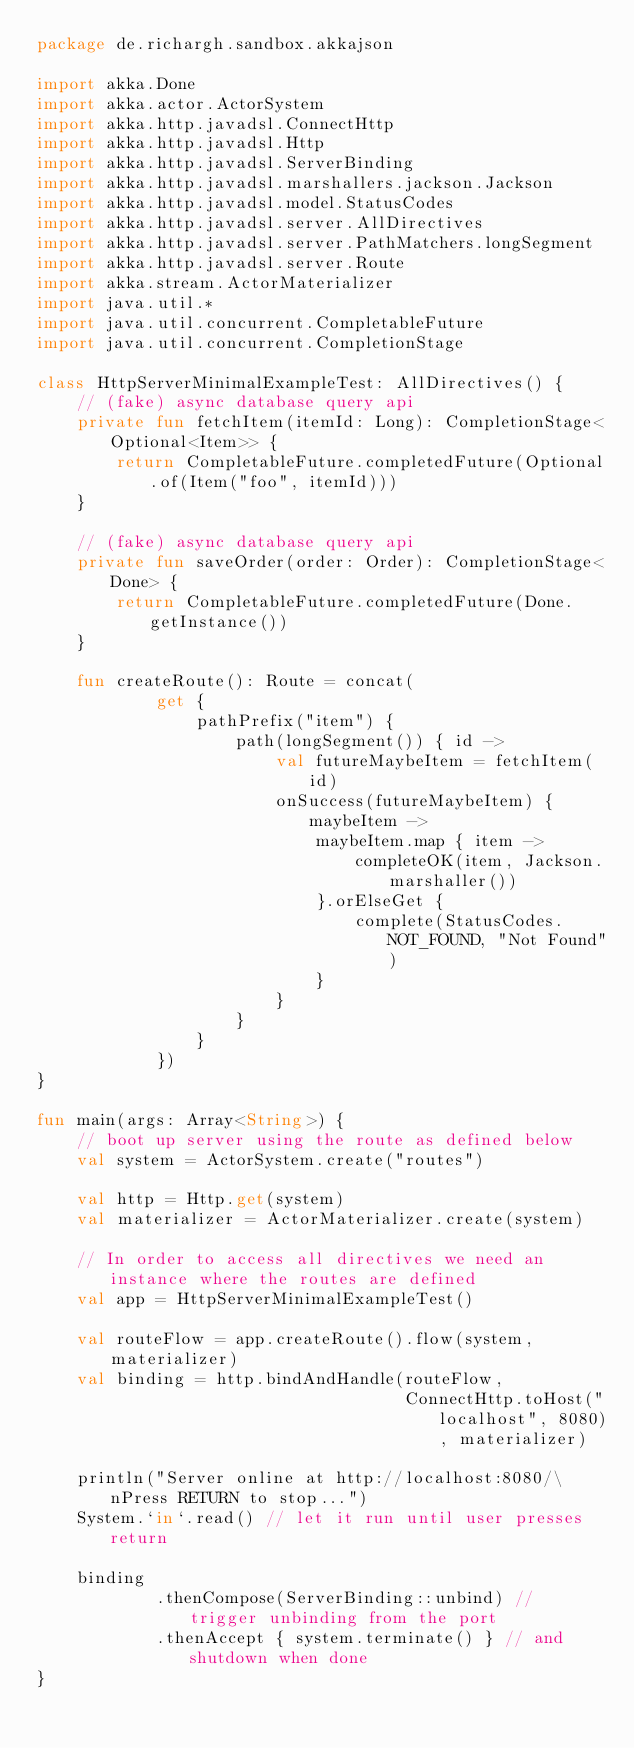Convert code to text. <code><loc_0><loc_0><loc_500><loc_500><_Kotlin_>package de.richargh.sandbox.akkajson

import akka.Done
import akka.actor.ActorSystem
import akka.http.javadsl.ConnectHttp
import akka.http.javadsl.Http
import akka.http.javadsl.ServerBinding
import akka.http.javadsl.marshallers.jackson.Jackson
import akka.http.javadsl.model.StatusCodes
import akka.http.javadsl.server.AllDirectives
import akka.http.javadsl.server.PathMatchers.longSegment
import akka.http.javadsl.server.Route
import akka.stream.ActorMaterializer
import java.util.*
import java.util.concurrent.CompletableFuture
import java.util.concurrent.CompletionStage

class HttpServerMinimalExampleTest: AllDirectives() {
    // (fake) async database query api
    private fun fetchItem(itemId: Long): CompletionStage<Optional<Item>> {
        return CompletableFuture.completedFuture(Optional.of(Item("foo", itemId)))
    }

    // (fake) async database query api
    private fun saveOrder(order: Order): CompletionStage<Done> {
        return CompletableFuture.completedFuture(Done.getInstance())
    }

    fun createRoute(): Route = concat(
            get {
                pathPrefix("item") {
                    path(longSegment()) { id ->
                        val futureMaybeItem = fetchItem(id)
                        onSuccess(futureMaybeItem) { maybeItem ->
                            maybeItem.map { item ->
                                completeOK(item, Jackson.marshaller())
                            }.orElseGet {
                                complete(StatusCodes.NOT_FOUND, "Not Found")
                            }
                        }
                    }
                }
            })
}

fun main(args: Array<String>) {
    // boot up server using the route as defined below
    val system = ActorSystem.create("routes")

    val http = Http.get(system)
    val materializer = ActorMaterializer.create(system)

    // In order to access all directives we need an instance where the routes are defined
    val app = HttpServerMinimalExampleTest()

    val routeFlow = app.createRoute().flow(system, materializer)
    val binding = http.bindAndHandle(routeFlow,
                                     ConnectHttp.toHost("localhost", 8080), materializer)

    println("Server online at http://localhost:8080/\nPress RETURN to stop...")
    System.`in`.read() // let it run until user presses return

    binding
            .thenCompose(ServerBinding::unbind) // trigger unbinding from the port
            .thenAccept { system.terminate() } // and shutdown when done
}</code> 